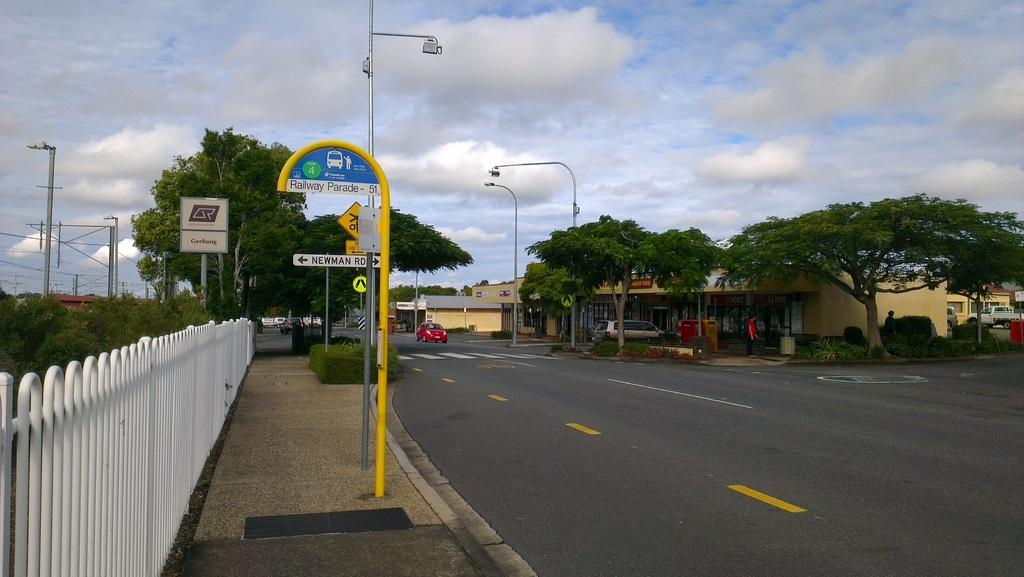<image>
Create a compact narrative representing the image presented. According to the sign Newman Road is on the left. 